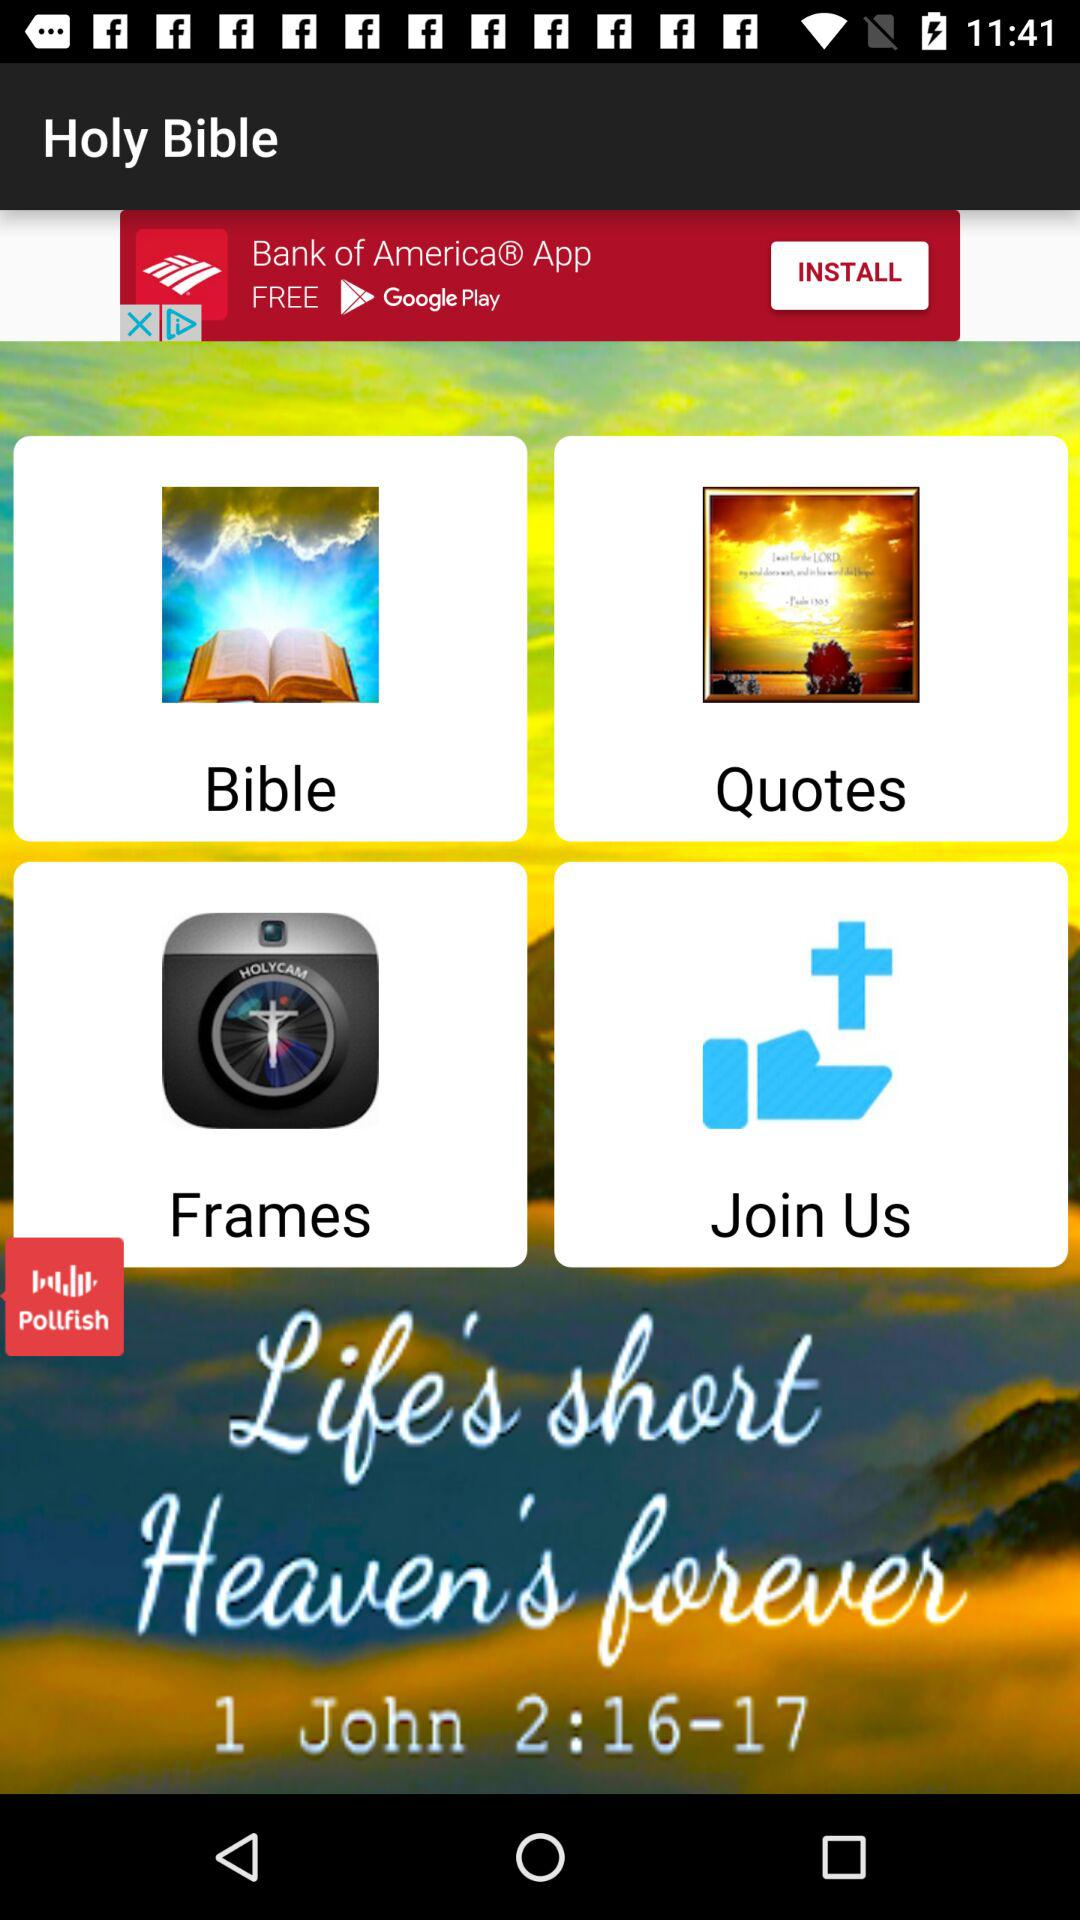Which date is shown on the screen?
When the provided information is insufficient, respond with <no answer>. <no answer> 